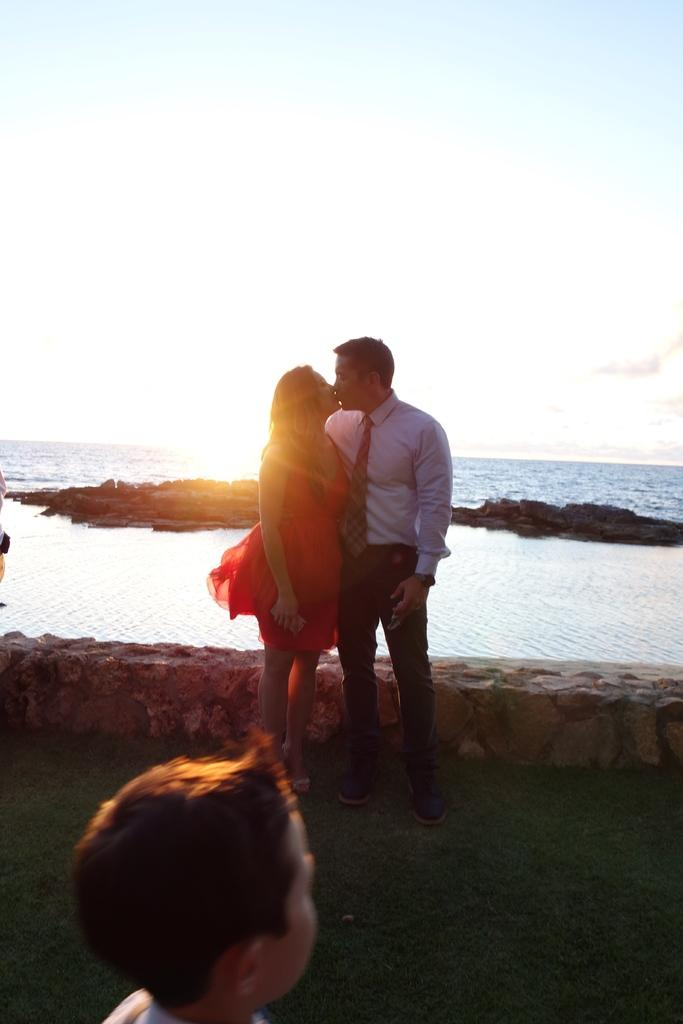How many people are present in the image? There are two people standing in the image. What is the position of the boy in relation to the people? There is a boy in front of the people. What can be seen in the background of the image? Water and the sky are visible in the background. What type of teeth can be seen in the image? There are no teeth visible in the image. What order are the people standing in? The facts provided do not specify the order in which the people are standing. 